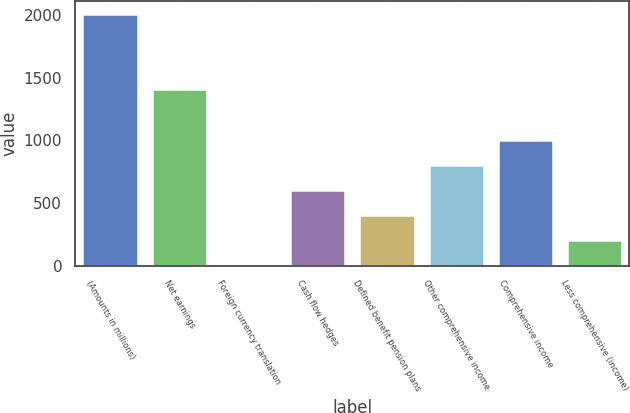Convert chart. <chart><loc_0><loc_0><loc_500><loc_500><bar_chart><fcel>(Amounts in millions)<fcel>Net earnings<fcel>Foreign currency translation<fcel>Cash flow hedges<fcel>Defined benefit pension plans<fcel>Other comprehensive income<fcel>Comprehensive income<fcel>Less comprehensive (income)<nl><fcel>2011<fcel>1408.54<fcel>2.8<fcel>605.26<fcel>404.44<fcel>806.08<fcel>1006.9<fcel>203.62<nl></chart> 